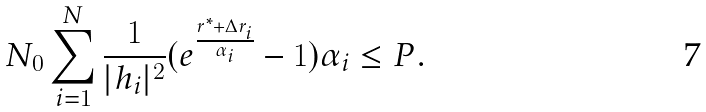<formula> <loc_0><loc_0><loc_500><loc_500>N _ { 0 } \sum _ { i = 1 } ^ { N } \frac { 1 } { | h _ { i } | ^ { 2 } } ( e ^ { \frac { r ^ { * } + \Delta r _ { i } } { \alpha _ { i } } } - 1 ) \alpha _ { i } \leq P .</formula> 